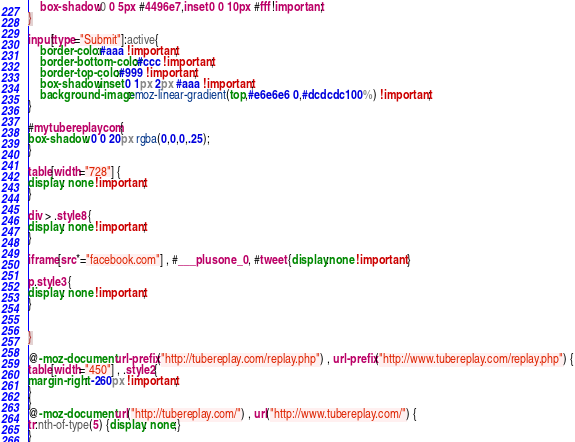Convert code to text. <code><loc_0><loc_0><loc_500><loc_500><_CSS_>	box-shadow:0 0 5px #4496e7,inset 0 0 10px #fff !important;
}

input[type="Submit"]:active{
	border-color:#aaa !important;
	border-bottom-color:#ccc !important;
	border-top-color:#999 !important;
	box-shadow:inset 0 1px 2px #aaa !important;
	background-image:-moz-linear-gradient(top,#e6e6e6 0,#dcdcdc 100%) !important;
}

#mytubereplaycom {
box-shadow: 0 0 20px rgba(0,0,0,.25);
}

table[width="728"] {
display: none !important;
}

div > .style8 {
display: none !important;
}

iframe[src*="facebook.com"] , #___plusone_0 , #tweet {display:none !important }

p.style3 {
display: none !important;
}


}

@-moz-document url-prefix("http://tubereplay.com/replay.php") , url-prefix("http://www.tubereplay.com/replay.php") {
table[width="450"] , .style2{
margin-right: -260px !important;
}
}
@-moz-document url("http://tubereplay.com/") , url("http://www.tubereplay.com/") {
tr:nth-of-type(5) {display: none;}
}
</code> 